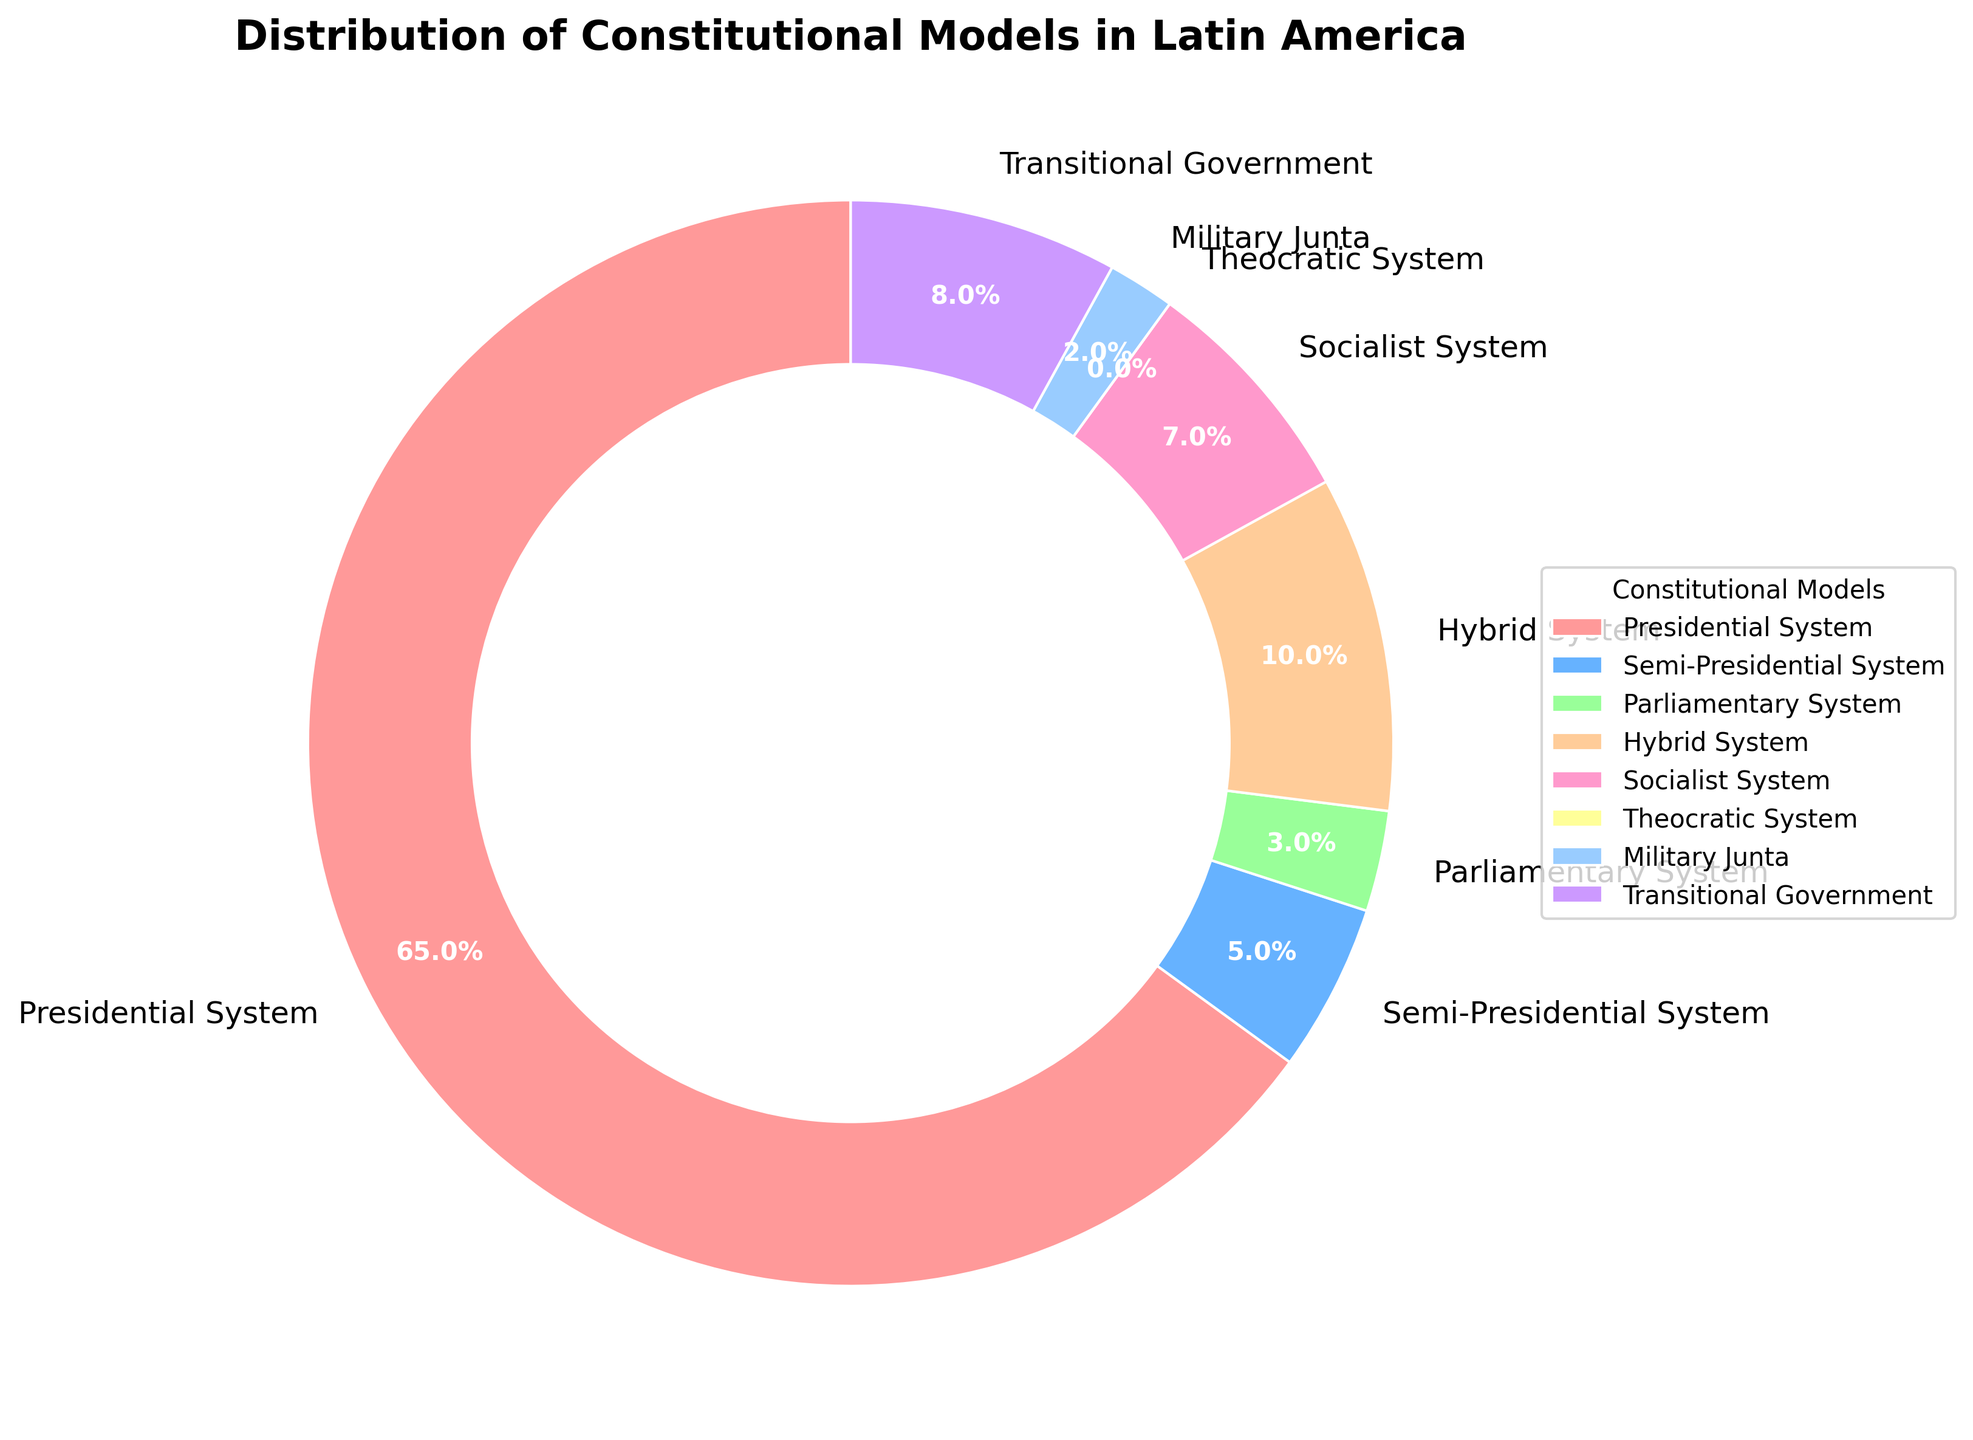Which constitutional model is the most common in Latin America? By glancing at the chart, the "Presidential System" occupies the largest portion of the donut chart.
Answer: Presidential System What is the combined percentage of hybrid and socialist systems? The hybrid system has 10% and the socialist system has 7%. Adding these gives 10% + 7% = 17%.
Answer: 17% How many types of constitutional models have a percentage greater than 5%? The models with percentages greater than 5% are: Presidential System (65%), Hybrid System (10%), Socialist System (7%), and Transitional Government (8%). That's a total of 4 models.
Answer: 4 Which model is represented by the blue color? The blue color in the donut chart corresponds to the "Semi-Presidential System" as indicated by the legend.
Answer: Semi-Presidential System Is the military junta type more common than the parliamentary system? The military junta system is at 2% and the parliamentary system at 3%. Therefore, the parliamentary system is more common than the military junta.
Answer: No What is the difference in percentage between the least common and the most common constitutional model? The most common model is the Presidential System at 65%, and the least common excluding those with 0%, is the Military Junta at 2%. The difference is 65% - 2% = 63%.
Answer: 63% Are there more countries with a transitional or socialist system? Transitional Government system is 8% and Socialist System is 7%. Therefore, more countries have a Transitional Government system.
Answer: Transitional Government What is the percentage of countries with some form of non-traditional government models (sum of Hybrid, Transitional Government, and Military Junta)? Hybrid System is 10%, Transitional Government is 8%, and Military Junta is 2%. Adding these gives 10% + 8% + 2% = 20%.
Answer: 20% Which system has the smallest representation on the chart? The "Theocratic System" shows 0% indicating no representation.
Answer: Theocratic System What color represents the Hybrid System and what is its percentage? The Hybrid System is represented by a yellow-orange color and has a percentage of 10%.
Answer: Yellow-orange, 10% 